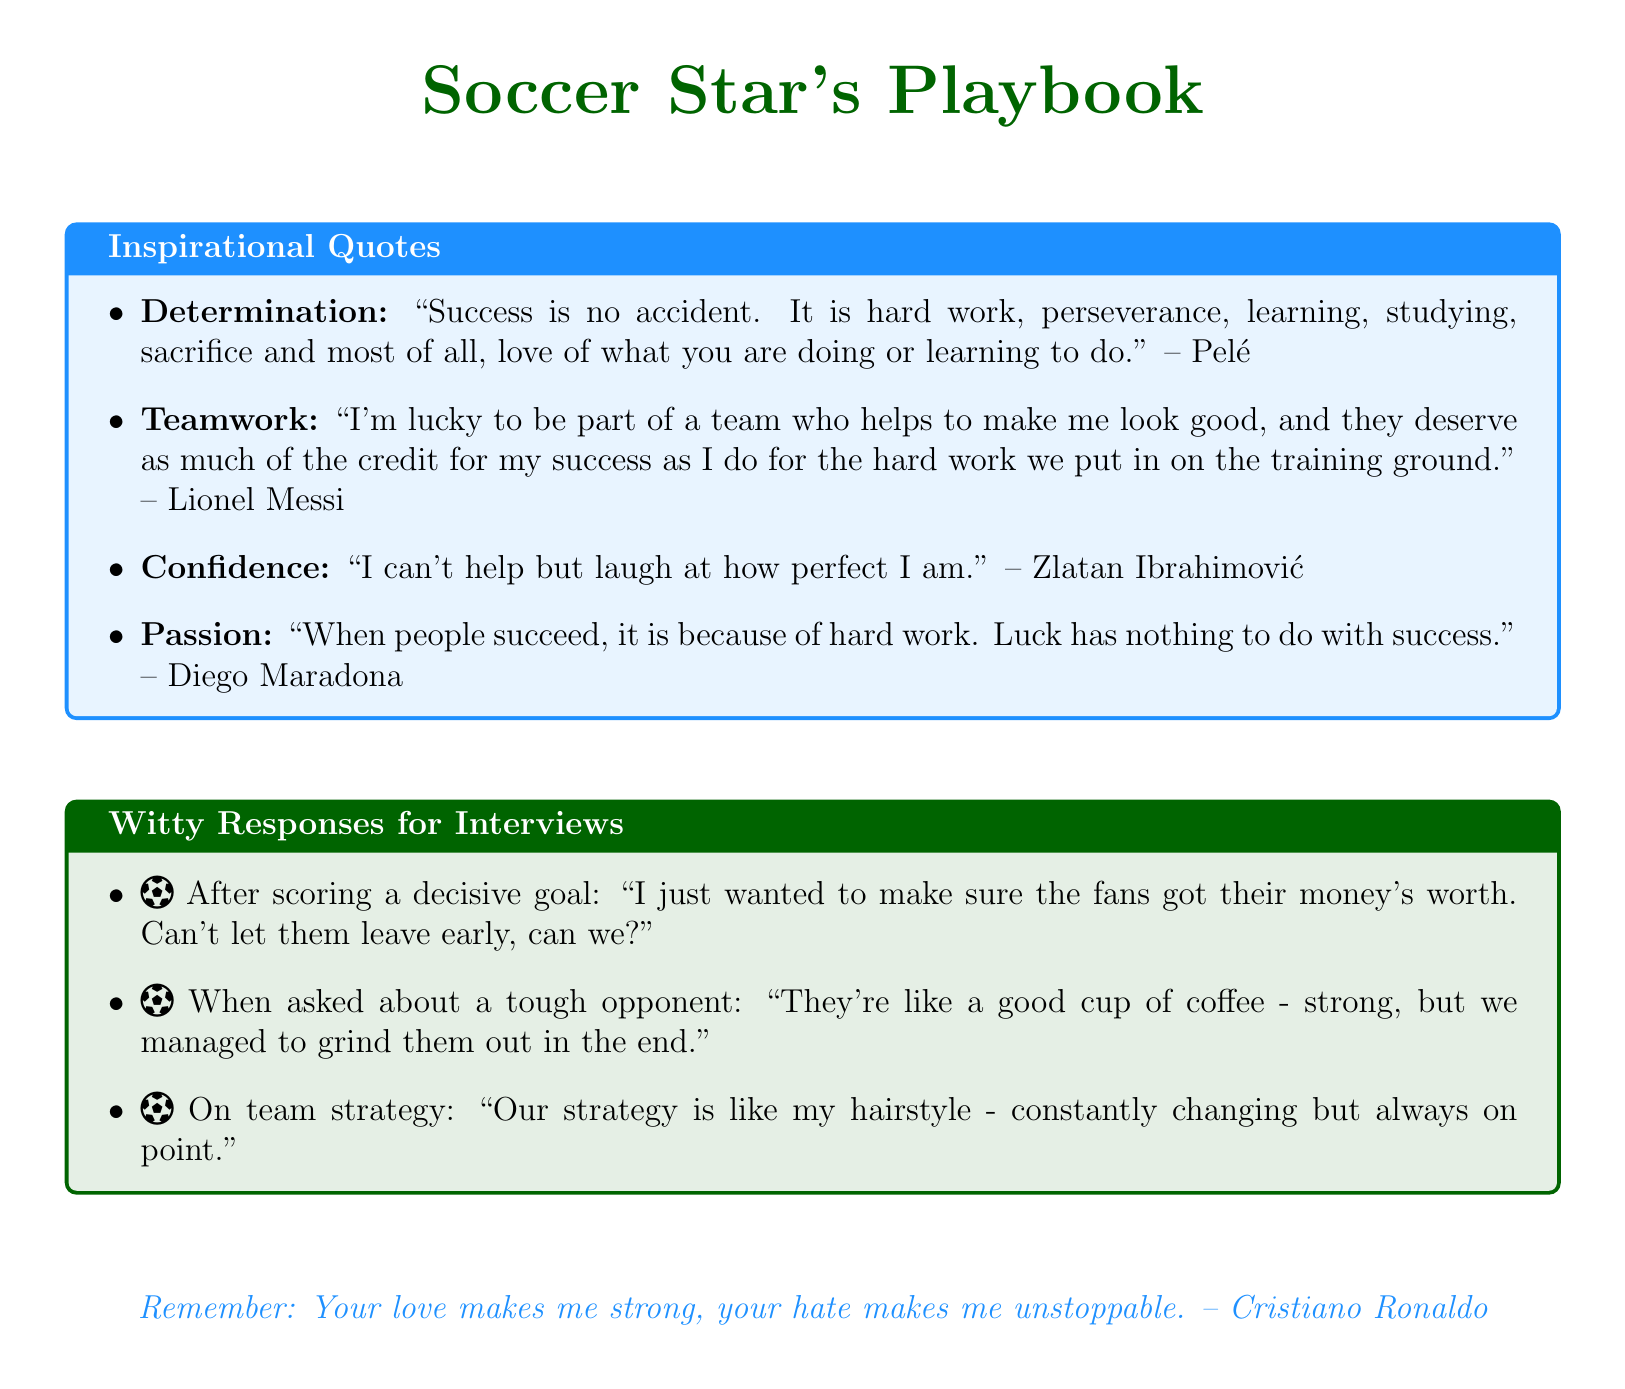What are the themes covered in the quotes? The document lists several themes under which the inspirational quotes are categorized: Determination, Teamwork, Confidence, and Passion.
Answer: Determination, Teamwork, Confidence, Passion Who quoted about teamwork? The document states that Lionel Messi and Abby Wambach both provided quotes on the theme of teamwork.
Answer: Lionel Messi, Abby Wambach What quote does Zlatan Ibrahimović provide? According to the document, Zlatan Ibrahimović's quote relates to confidence, specifically stating a humorous take on his self-view.
Answer: I can't help but laugh at how perfect I am How many witty responses are provided in the document? The document presents three witty responses tailored for different interview scenarios after a soccer match.
Answer: Three What is the main focus of Mia Hamm's quote? Mia Hamm's quote emphasizes the importance of consistent training and preparation leading up to a moment of achievement.
Answer: Building a fire with training Which player mentioned luck in their quote? The document includes a quote from Diego Maradona discussing success in relation to hard work, indicating he does not attribute success to luck.
Answer: Diego Maradona What style of document is this? The document is a collection of memorable quotes categorized by themes, accompanied by witty responses for interviews.
Answer: Notes What is a common purpose of the quotes listed in the document? The quotes aim to inspire readers by providing insights from legendary soccer players about key themes like determination and teamwork.
Answer: Inspiration 